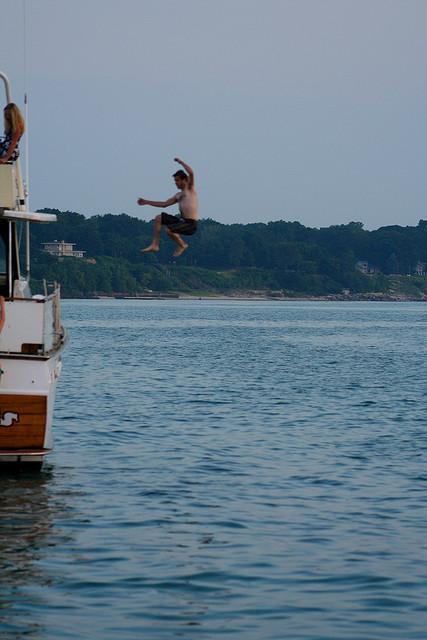Where does the man want to go?
Select the correct answer and articulate reasoning with the following format: 'Answer: answer
Rationale: rationale.'
Options: In raft, in water, on land, on boat. Answer: in water.
Rationale: The man wants to jump into the ocean. 